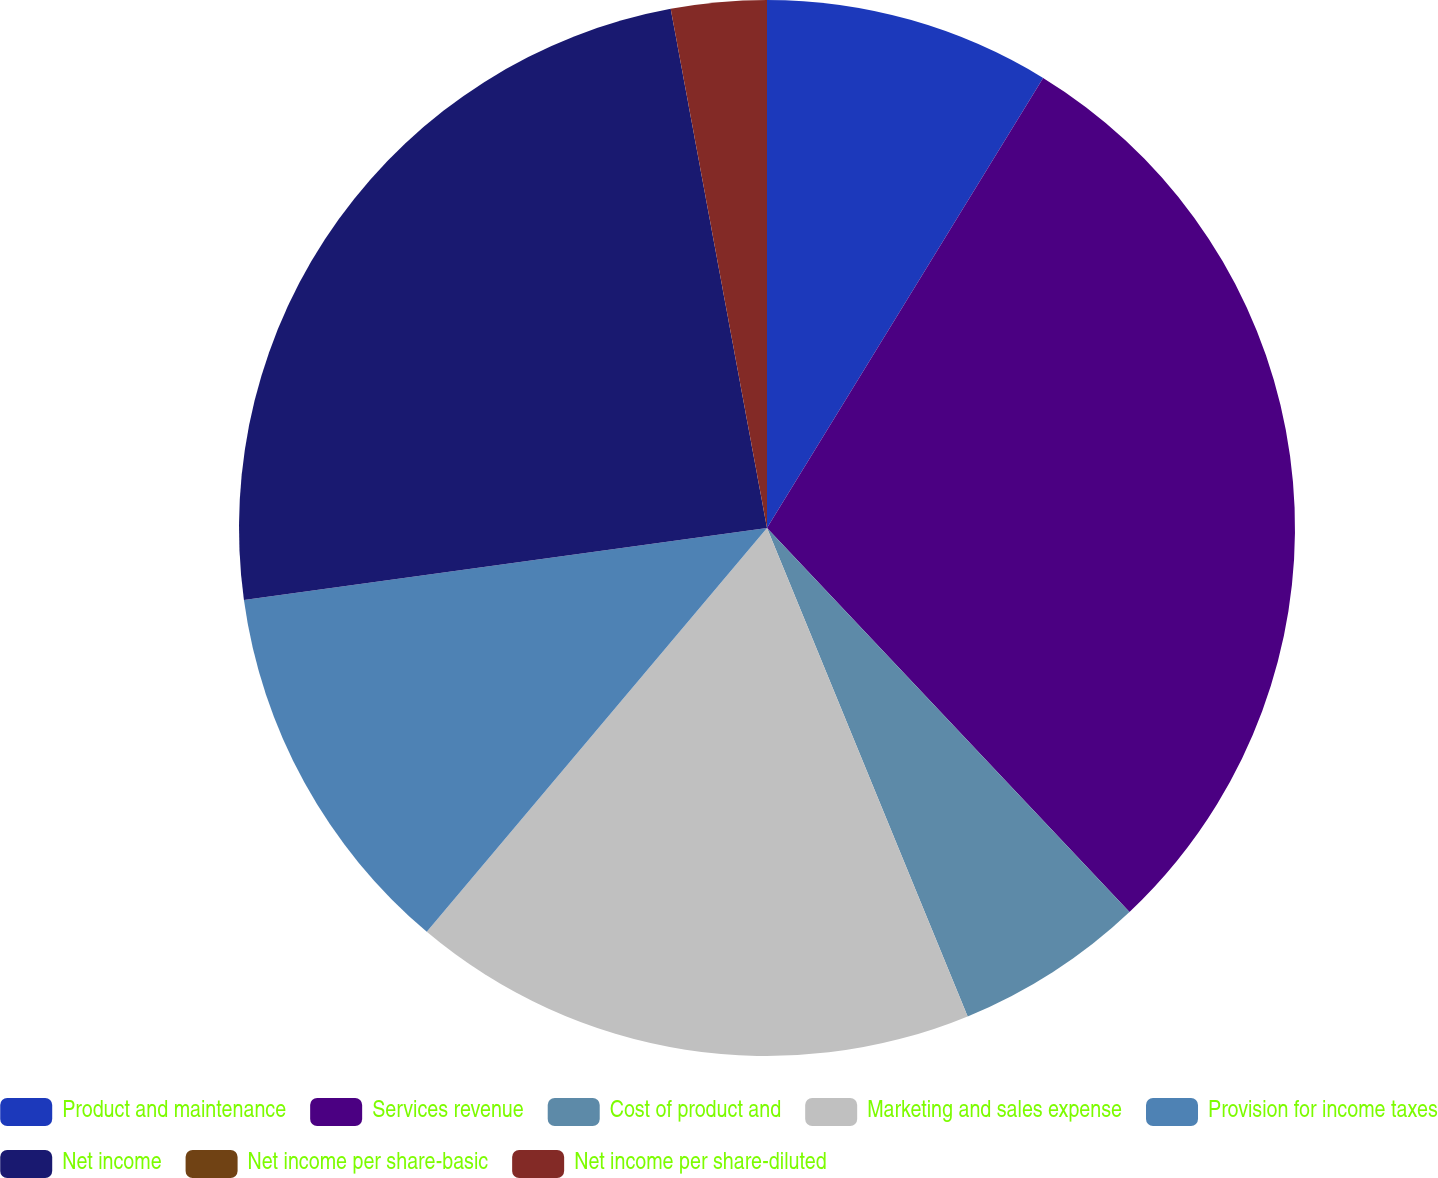<chart> <loc_0><loc_0><loc_500><loc_500><pie_chart><fcel>Product and maintenance<fcel>Services revenue<fcel>Cost of product and<fcel>Marketing and sales expense<fcel>Provision for income taxes<fcel>Net income<fcel>Net income per share-basic<fcel>Net income per share-diluted<nl><fcel>8.76%<fcel>29.2%<fcel>5.84%<fcel>17.35%<fcel>11.68%<fcel>24.26%<fcel>0.0%<fcel>2.92%<nl></chart> 